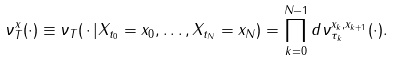<formula> <loc_0><loc_0><loc_500><loc_500>\nu _ { T } ^ { x } ( \cdot ) \equiv \nu _ { T } ( \, \cdot \, | X _ { t _ { 0 } } = x _ { 0 } , \dots , X _ { t _ { N } } = x _ { N } ) = \prod _ { k = 0 } ^ { N - 1 } d \nu _ { \tau _ { k } } ^ { x _ { k } , x _ { k + 1 } } ( \cdot ) .</formula> 